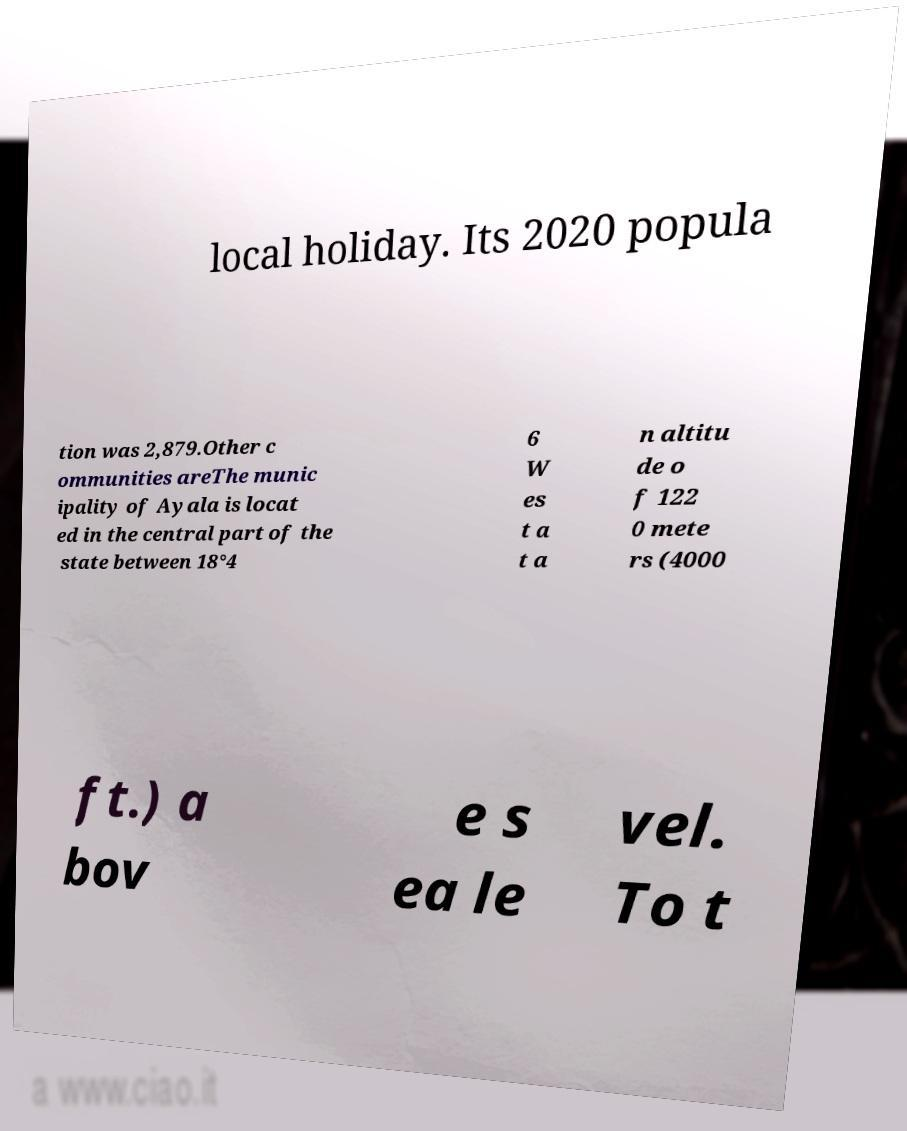Could you assist in decoding the text presented in this image and type it out clearly? local holiday. Its 2020 popula tion was 2,879.Other c ommunities areThe munic ipality of Ayala is locat ed in the central part of the state between 18°4 6 W es t a t a n altitu de o f 122 0 mete rs (4000 ft.) a bov e s ea le vel. To t 